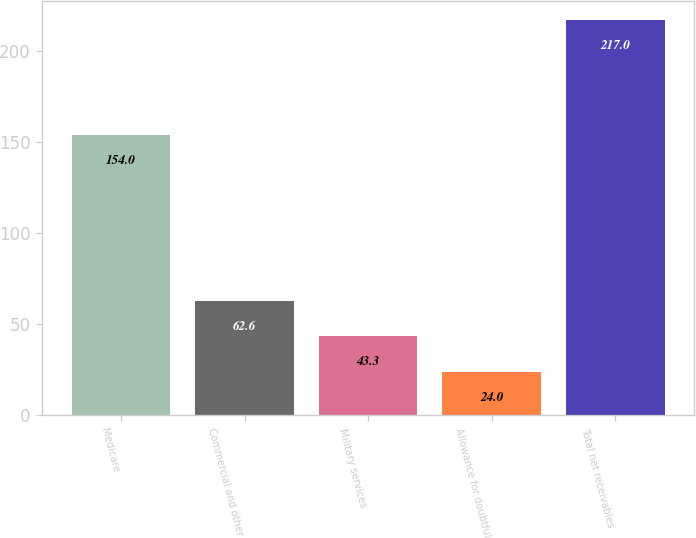<chart> <loc_0><loc_0><loc_500><loc_500><bar_chart><fcel>Medicare<fcel>Commercial and other<fcel>Military services<fcel>Allowance for doubtful<fcel>Total net receivables<nl><fcel>154<fcel>62.6<fcel>43.3<fcel>24<fcel>217<nl></chart> 